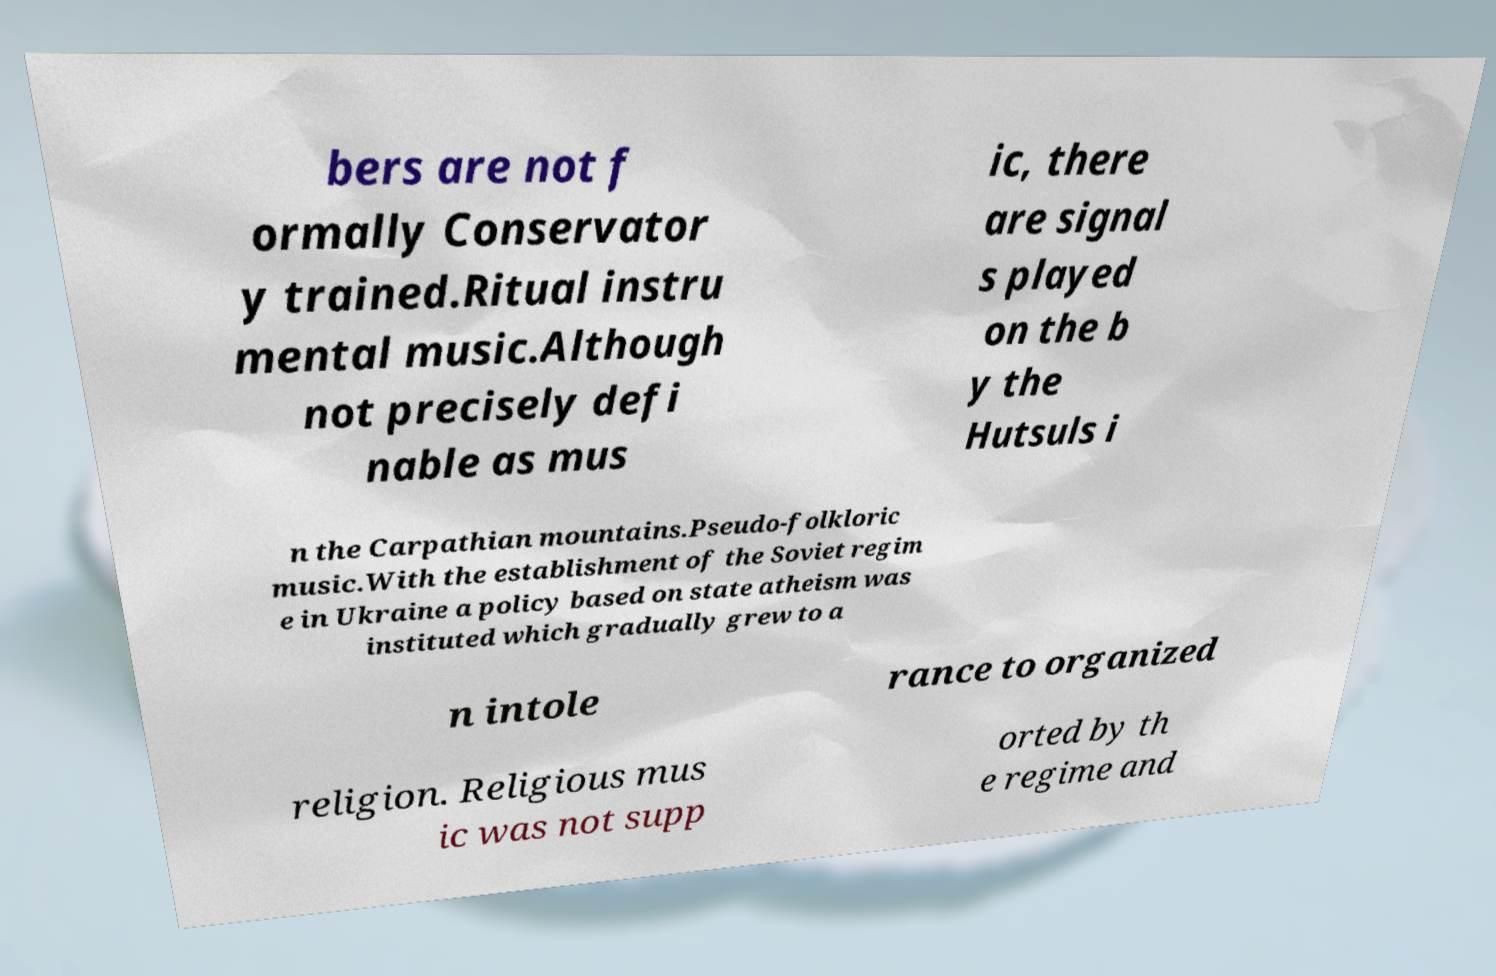There's text embedded in this image that I need extracted. Can you transcribe it verbatim? bers are not f ormally Conservator y trained.Ritual instru mental music.Although not precisely defi nable as mus ic, there are signal s played on the b y the Hutsuls i n the Carpathian mountains.Pseudo-folkloric music.With the establishment of the Soviet regim e in Ukraine a policy based on state atheism was instituted which gradually grew to a n intole rance to organized religion. Religious mus ic was not supp orted by th e regime and 